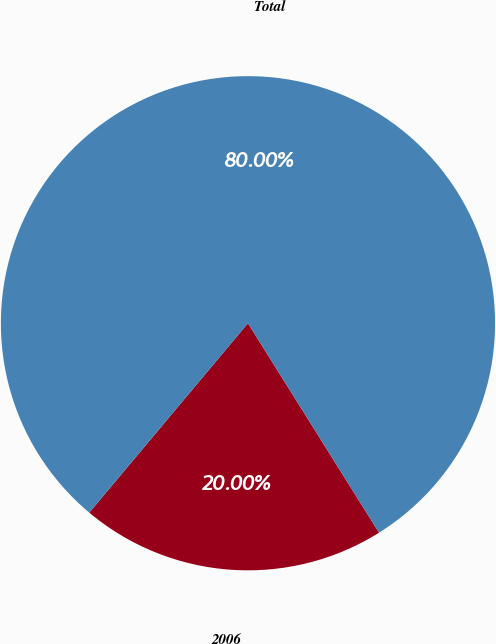Convert chart. <chart><loc_0><loc_0><loc_500><loc_500><pie_chart><fcel>2006<fcel>Total<nl><fcel>20.0%<fcel>80.0%<nl></chart> 